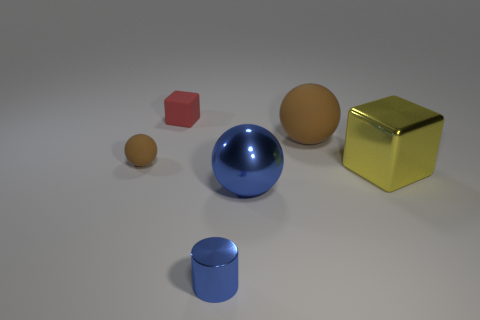Subtract all metal spheres. How many spheres are left? 2 Add 4 metallic cylinders. How many objects exist? 10 Subtract all blue spheres. How many spheres are left? 2 Subtract all cylinders. How many objects are left? 5 Add 5 big balls. How many big balls exist? 7 Subtract 0 purple spheres. How many objects are left? 6 Subtract 3 balls. How many balls are left? 0 Subtract all gray cylinders. Subtract all green cubes. How many cylinders are left? 1 Subtract all brown blocks. How many brown spheres are left? 2 Subtract all large red balls. Subtract all tiny metallic objects. How many objects are left? 5 